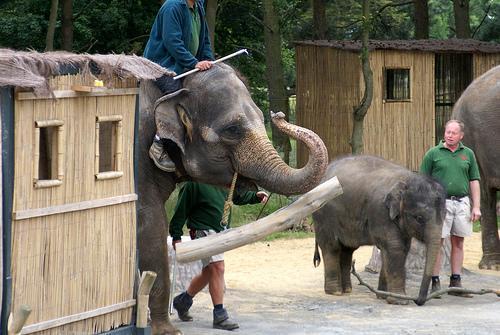How many elephants that are carrying a human are there? there are normal elephants too?
Give a very brief answer. 1. 